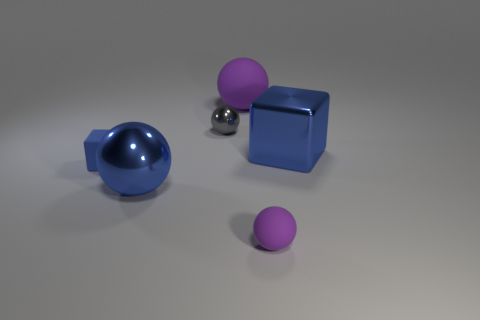Subtract all big blue balls. How many balls are left? 3 Add 3 large purple balls. How many objects exist? 9 Subtract all purple balls. How many balls are left? 2 Subtract all yellow cylinders. How many purple spheres are left? 2 Subtract 0 green balls. How many objects are left? 6 Subtract all cubes. How many objects are left? 4 Subtract 2 cubes. How many cubes are left? 0 Subtract all red balls. Subtract all purple cubes. How many balls are left? 4 Subtract all large purple matte objects. Subtract all tiny shiny objects. How many objects are left? 4 Add 2 tiny metal balls. How many tiny metal balls are left? 3 